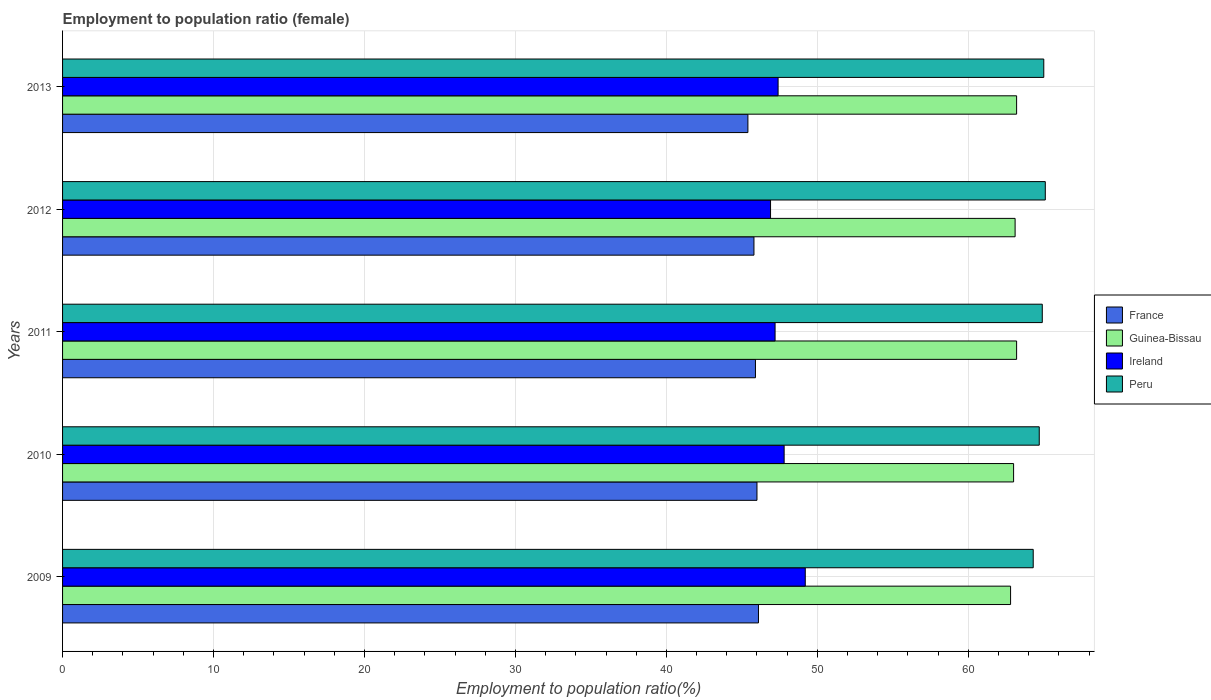How many groups of bars are there?
Your response must be concise. 5. Are the number of bars on each tick of the Y-axis equal?
Your answer should be compact. Yes. How many bars are there on the 4th tick from the bottom?
Offer a terse response. 4. What is the employment to population ratio in Peru in 2011?
Your response must be concise. 64.9. Across all years, what is the maximum employment to population ratio in Guinea-Bissau?
Provide a short and direct response. 63.2. Across all years, what is the minimum employment to population ratio in Peru?
Offer a very short reply. 64.3. What is the total employment to population ratio in Ireland in the graph?
Provide a short and direct response. 238.5. What is the difference between the employment to population ratio in Guinea-Bissau in 2009 and that in 2011?
Provide a short and direct response. -0.4. What is the difference between the employment to population ratio in Ireland in 2009 and the employment to population ratio in France in 2011?
Offer a terse response. 3.3. What is the average employment to population ratio in Ireland per year?
Make the answer very short. 47.7. In the year 2010, what is the difference between the employment to population ratio in Guinea-Bissau and employment to population ratio in Peru?
Make the answer very short. -1.7. What is the ratio of the employment to population ratio in Guinea-Bissau in 2010 to that in 2011?
Provide a succinct answer. 1. Is the employment to population ratio in France in 2010 less than that in 2012?
Make the answer very short. No. What is the difference between the highest and the second highest employment to population ratio in France?
Keep it short and to the point. 0.1. What is the difference between the highest and the lowest employment to population ratio in Peru?
Your response must be concise. 0.8. In how many years, is the employment to population ratio in France greater than the average employment to population ratio in France taken over all years?
Ensure brevity in your answer.  3. Is the sum of the employment to population ratio in Guinea-Bissau in 2009 and 2010 greater than the maximum employment to population ratio in Peru across all years?
Your answer should be very brief. Yes. Is it the case that in every year, the sum of the employment to population ratio in Guinea-Bissau and employment to population ratio in France is greater than the sum of employment to population ratio in Ireland and employment to population ratio in Peru?
Provide a succinct answer. No. What does the 3rd bar from the top in 2009 represents?
Provide a succinct answer. Guinea-Bissau. What does the 4th bar from the bottom in 2012 represents?
Your response must be concise. Peru. How many bars are there?
Ensure brevity in your answer.  20. Are all the bars in the graph horizontal?
Your answer should be very brief. Yes. Are the values on the major ticks of X-axis written in scientific E-notation?
Your answer should be compact. No. Does the graph contain any zero values?
Offer a terse response. No. Does the graph contain grids?
Give a very brief answer. Yes. Where does the legend appear in the graph?
Your answer should be very brief. Center right. How are the legend labels stacked?
Provide a succinct answer. Vertical. What is the title of the graph?
Your response must be concise. Employment to population ratio (female). Does "Greenland" appear as one of the legend labels in the graph?
Make the answer very short. No. What is the Employment to population ratio(%) of France in 2009?
Give a very brief answer. 46.1. What is the Employment to population ratio(%) of Guinea-Bissau in 2009?
Your response must be concise. 62.8. What is the Employment to population ratio(%) in Ireland in 2009?
Ensure brevity in your answer.  49.2. What is the Employment to population ratio(%) in Peru in 2009?
Offer a very short reply. 64.3. What is the Employment to population ratio(%) of France in 2010?
Offer a terse response. 46. What is the Employment to population ratio(%) in Guinea-Bissau in 2010?
Your response must be concise. 63. What is the Employment to population ratio(%) of Ireland in 2010?
Provide a short and direct response. 47.8. What is the Employment to population ratio(%) in Peru in 2010?
Make the answer very short. 64.7. What is the Employment to population ratio(%) of France in 2011?
Provide a short and direct response. 45.9. What is the Employment to population ratio(%) of Guinea-Bissau in 2011?
Give a very brief answer. 63.2. What is the Employment to population ratio(%) in Ireland in 2011?
Your answer should be very brief. 47.2. What is the Employment to population ratio(%) in Peru in 2011?
Ensure brevity in your answer.  64.9. What is the Employment to population ratio(%) of France in 2012?
Make the answer very short. 45.8. What is the Employment to population ratio(%) of Guinea-Bissau in 2012?
Give a very brief answer. 63.1. What is the Employment to population ratio(%) in Ireland in 2012?
Make the answer very short. 46.9. What is the Employment to population ratio(%) of Peru in 2012?
Provide a succinct answer. 65.1. What is the Employment to population ratio(%) of France in 2013?
Offer a terse response. 45.4. What is the Employment to population ratio(%) in Guinea-Bissau in 2013?
Make the answer very short. 63.2. What is the Employment to population ratio(%) of Ireland in 2013?
Offer a terse response. 47.4. What is the Employment to population ratio(%) of Peru in 2013?
Your response must be concise. 65. Across all years, what is the maximum Employment to population ratio(%) of France?
Your response must be concise. 46.1. Across all years, what is the maximum Employment to population ratio(%) of Guinea-Bissau?
Your answer should be compact. 63.2. Across all years, what is the maximum Employment to population ratio(%) of Ireland?
Your answer should be compact. 49.2. Across all years, what is the maximum Employment to population ratio(%) of Peru?
Your answer should be compact. 65.1. Across all years, what is the minimum Employment to population ratio(%) of France?
Your answer should be very brief. 45.4. Across all years, what is the minimum Employment to population ratio(%) of Guinea-Bissau?
Ensure brevity in your answer.  62.8. Across all years, what is the minimum Employment to population ratio(%) of Ireland?
Offer a terse response. 46.9. Across all years, what is the minimum Employment to population ratio(%) in Peru?
Your answer should be compact. 64.3. What is the total Employment to population ratio(%) in France in the graph?
Provide a succinct answer. 229.2. What is the total Employment to population ratio(%) in Guinea-Bissau in the graph?
Make the answer very short. 315.3. What is the total Employment to population ratio(%) in Ireland in the graph?
Your answer should be very brief. 238.5. What is the total Employment to population ratio(%) of Peru in the graph?
Offer a very short reply. 324. What is the difference between the Employment to population ratio(%) of Guinea-Bissau in 2009 and that in 2010?
Offer a terse response. -0.2. What is the difference between the Employment to population ratio(%) of Peru in 2009 and that in 2010?
Offer a very short reply. -0.4. What is the difference between the Employment to population ratio(%) of France in 2009 and that in 2011?
Your answer should be compact. 0.2. What is the difference between the Employment to population ratio(%) of Guinea-Bissau in 2009 and that in 2011?
Your answer should be very brief. -0.4. What is the difference between the Employment to population ratio(%) in Ireland in 2009 and that in 2011?
Ensure brevity in your answer.  2. What is the difference between the Employment to population ratio(%) in France in 2009 and that in 2012?
Your response must be concise. 0.3. What is the difference between the Employment to population ratio(%) of Peru in 2009 and that in 2012?
Give a very brief answer. -0.8. What is the difference between the Employment to population ratio(%) of Guinea-Bissau in 2009 and that in 2013?
Ensure brevity in your answer.  -0.4. What is the difference between the Employment to population ratio(%) in Ireland in 2010 and that in 2011?
Ensure brevity in your answer.  0.6. What is the difference between the Employment to population ratio(%) of Guinea-Bissau in 2010 and that in 2012?
Give a very brief answer. -0.1. What is the difference between the Employment to population ratio(%) of Ireland in 2010 and that in 2012?
Your answer should be compact. 0.9. What is the difference between the Employment to population ratio(%) of Guinea-Bissau in 2010 and that in 2013?
Ensure brevity in your answer.  -0.2. What is the difference between the Employment to population ratio(%) of Ireland in 2010 and that in 2013?
Your response must be concise. 0.4. What is the difference between the Employment to population ratio(%) of Peru in 2010 and that in 2013?
Give a very brief answer. -0.3. What is the difference between the Employment to population ratio(%) in Guinea-Bissau in 2011 and that in 2012?
Provide a short and direct response. 0.1. What is the difference between the Employment to population ratio(%) in Peru in 2011 and that in 2012?
Make the answer very short. -0.2. What is the difference between the Employment to population ratio(%) in France in 2011 and that in 2013?
Provide a short and direct response. 0.5. What is the difference between the Employment to population ratio(%) of Guinea-Bissau in 2011 and that in 2013?
Offer a very short reply. 0. What is the difference between the Employment to population ratio(%) in Peru in 2011 and that in 2013?
Make the answer very short. -0.1. What is the difference between the Employment to population ratio(%) of Ireland in 2012 and that in 2013?
Keep it short and to the point. -0.5. What is the difference between the Employment to population ratio(%) in Peru in 2012 and that in 2013?
Provide a short and direct response. 0.1. What is the difference between the Employment to population ratio(%) in France in 2009 and the Employment to population ratio(%) in Guinea-Bissau in 2010?
Offer a terse response. -16.9. What is the difference between the Employment to population ratio(%) in France in 2009 and the Employment to population ratio(%) in Ireland in 2010?
Provide a short and direct response. -1.7. What is the difference between the Employment to population ratio(%) of France in 2009 and the Employment to population ratio(%) of Peru in 2010?
Give a very brief answer. -18.6. What is the difference between the Employment to population ratio(%) in Guinea-Bissau in 2009 and the Employment to population ratio(%) in Ireland in 2010?
Your answer should be compact. 15. What is the difference between the Employment to population ratio(%) in Ireland in 2009 and the Employment to population ratio(%) in Peru in 2010?
Provide a short and direct response. -15.5. What is the difference between the Employment to population ratio(%) of France in 2009 and the Employment to population ratio(%) of Guinea-Bissau in 2011?
Your response must be concise. -17.1. What is the difference between the Employment to population ratio(%) in France in 2009 and the Employment to population ratio(%) in Ireland in 2011?
Your answer should be very brief. -1.1. What is the difference between the Employment to population ratio(%) in France in 2009 and the Employment to population ratio(%) in Peru in 2011?
Your response must be concise. -18.8. What is the difference between the Employment to population ratio(%) of Ireland in 2009 and the Employment to population ratio(%) of Peru in 2011?
Offer a terse response. -15.7. What is the difference between the Employment to population ratio(%) of Ireland in 2009 and the Employment to population ratio(%) of Peru in 2012?
Make the answer very short. -15.9. What is the difference between the Employment to population ratio(%) of France in 2009 and the Employment to population ratio(%) of Guinea-Bissau in 2013?
Provide a succinct answer. -17.1. What is the difference between the Employment to population ratio(%) of France in 2009 and the Employment to population ratio(%) of Ireland in 2013?
Offer a terse response. -1.3. What is the difference between the Employment to population ratio(%) in France in 2009 and the Employment to population ratio(%) in Peru in 2013?
Ensure brevity in your answer.  -18.9. What is the difference between the Employment to population ratio(%) of Guinea-Bissau in 2009 and the Employment to population ratio(%) of Peru in 2013?
Provide a short and direct response. -2.2. What is the difference between the Employment to population ratio(%) of Ireland in 2009 and the Employment to population ratio(%) of Peru in 2013?
Your answer should be very brief. -15.8. What is the difference between the Employment to population ratio(%) in France in 2010 and the Employment to population ratio(%) in Guinea-Bissau in 2011?
Make the answer very short. -17.2. What is the difference between the Employment to population ratio(%) in France in 2010 and the Employment to population ratio(%) in Ireland in 2011?
Keep it short and to the point. -1.2. What is the difference between the Employment to population ratio(%) in France in 2010 and the Employment to population ratio(%) in Peru in 2011?
Offer a very short reply. -18.9. What is the difference between the Employment to population ratio(%) of Guinea-Bissau in 2010 and the Employment to population ratio(%) of Ireland in 2011?
Your answer should be compact. 15.8. What is the difference between the Employment to population ratio(%) of Ireland in 2010 and the Employment to population ratio(%) of Peru in 2011?
Provide a succinct answer. -17.1. What is the difference between the Employment to population ratio(%) of France in 2010 and the Employment to population ratio(%) of Guinea-Bissau in 2012?
Ensure brevity in your answer.  -17.1. What is the difference between the Employment to population ratio(%) of France in 2010 and the Employment to population ratio(%) of Ireland in 2012?
Keep it short and to the point. -0.9. What is the difference between the Employment to population ratio(%) in France in 2010 and the Employment to population ratio(%) in Peru in 2012?
Offer a terse response. -19.1. What is the difference between the Employment to population ratio(%) in Guinea-Bissau in 2010 and the Employment to population ratio(%) in Ireland in 2012?
Offer a terse response. 16.1. What is the difference between the Employment to population ratio(%) of Ireland in 2010 and the Employment to population ratio(%) of Peru in 2012?
Your response must be concise. -17.3. What is the difference between the Employment to population ratio(%) of France in 2010 and the Employment to population ratio(%) of Guinea-Bissau in 2013?
Give a very brief answer. -17.2. What is the difference between the Employment to population ratio(%) in France in 2010 and the Employment to population ratio(%) in Peru in 2013?
Keep it short and to the point. -19. What is the difference between the Employment to population ratio(%) of Guinea-Bissau in 2010 and the Employment to population ratio(%) of Ireland in 2013?
Your answer should be very brief. 15.6. What is the difference between the Employment to population ratio(%) of Guinea-Bissau in 2010 and the Employment to population ratio(%) of Peru in 2013?
Offer a very short reply. -2. What is the difference between the Employment to population ratio(%) of Ireland in 2010 and the Employment to population ratio(%) of Peru in 2013?
Provide a short and direct response. -17.2. What is the difference between the Employment to population ratio(%) in France in 2011 and the Employment to population ratio(%) in Guinea-Bissau in 2012?
Ensure brevity in your answer.  -17.2. What is the difference between the Employment to population ratio(%) of France in 2011 and the Employment to population ratio(%) of Peru in 2012?
Provide a succinct answer. -19.2. What is the difference between the Employment to population ratio(%) of Guinea-Bissau in 2011 and the Employment to population ratio(%) of Peru in 2012?
Your response must be concise. -1.9. What is the difference between the Employment to population ratio(%) in Ireland in 2011 and the Employment to population ratio(%) in Peru in 2012?
Your response must be concise. -17.9. What is the difference between the Employment to population ratio(%) in France in 2011 and the Employment to population ratio(%) in Guinea-Bissau in 2013?
Provide a short and direct response. -17.3. What is the difference between the Employment to population ratio(%) of France in 2011 and the Employment to population ratio(%) of Ireland in 2013?
Give a very brief answer. -1.5. What is the difference between the Employment to population ratio(%) in France in 2011 and the Employment to population ratio(%) in Peru in 2013?
Give a very brief answer. -19.1. What is the difference between the Employment to population ratio(%) of Guinea-Bissau in 2011 and the Employment to population ratio(%) of Ireland in 2013?
Offer a terse response. 15.8. What is the difference between the Employment to population ratio(%) of Guinea-Bissau in 2011 and the Employment to population ratio(%) of Peru in 2013?
Keep it short and to the point. -1.8. What is the difference between the Employment to population ratio(%) in Ireland in 2011 and the Employment to population ratio(%) in Peru in 2013?
Make the answer very short. -17.8. What is the difference between the Employment to population ratio(%) of France in 2012 and the Employment to population ratio(%) of Guinea-Bissau in 2013?
Offer a very short reply. -17.4. What is the difference between the Employment to population ratio(%) of France in 2012 and the Employment to population ratio(%) of Peru in 2013?
Your response must be concise. -19.2. What is the difference between the Employment to population ratio(%) in Guinea-Bissau in 2012 and the Employment to population ratio(%) in Ireland in 2013?
Ensure brevity in your answer.  15.7. What is the difference between the Employment to population ratio(%) in Ireland in 2012 and the Employment to population ratio(%) in Peru in 2013?
Your response must be concise. -18.1. What is the average Employment to population ratio(%) in France per year?
Provide a short and direct response. 45.84. What is the average Employment to population ratio(%) in Guinea-Bissau per year?
Ensure brevity in your answer.  63.06. What is the average Employment to population ratio(%) of Ireland per year?
Your response must be concise. 47.7. What is the average Employment to population ratio(%) in Peru per year?
Your answer should be very brief. 64.8. In the year 2009, what is the difference between the Employment to population ratio(%) of France and Employment to population ratio(%) of Guinea-Bissau?
Provide a succinct answer. -16.7. In the year 2009, what is the difference between the Employment to population ratio(%) in France and Employment to population ratio(%) in Peru?
Ensure brevity in your answer.  -18.2. In the year 2009, what is the difference between the Employment to population ratio(%) in Guinea-Bissau and Employment to population ratio(%) in Ireland?
Ensure brevity in your answer.  13.6. In the year 2009, what is the difference between the Employment to population ratio(%) of Ireland and Employment to population ratio(%) of Peru?
Your answer should be compact. -15.1. In the year 2010, what is the difference between the Employment to population ratio(%) in France and Employment to population ratio(%) in Guinea-Bissau?
Offer a very short reply. -17. In the year 2010, what is the difference between the Employment to population ratio(%) of France and Employment to population ratio(%) of Ireland?
Ensure brevity in your answer.  -1.8. In the year 2010, what is the difference between the Employment to population ratio(%) of France and Employment to population ratio(%) of Peru?
Offer a very short reply. -18.7. In the year 2010, what is the difference between the Employment to population ratio(%) in Ireland and Employment to population ratio(%) in Peru?
Give a very brief answer. -16.9. In the year 2011, what is the difference between the Employment to population ratio(%) of France and Employment to population ratio(%) of Guinea-Bissau?
Provide a short and direct response. -17.3. In the year 2011, what is the difference between the Employment to population ratio(%) in France and Employment to population ratio(%) in Ireland?
Provide a succinct answer. -1.3. In the year 2011, what is the difference between the Employment to population ratio(%) of Guinea-Bissau and Employment to population ratio(%) of Ireland?
Ensure brevity in your answer.  16. In the year 2011, what is the difference between the Employment to population ratio(%) of Guinea-Bissau and Employment to population ratio(%) of Peru?
Your answer should be very brief. -1.7. In the year 2011, what is the difference between the Employment to population ratio(%) of Ireland and Employment to population ratio(%) of Peru?
Make the answer very short. -17.7. In the year 2012, what is the difference between the Employment to population ratio(%) of France and Employment to population ratio(%) of Guinea-Bissau?
Provide a succinct answer. -17.3. In the year 2012, what is the difference between the Employment to population ratio(%) of France and Employment to population ratio(%) of Ireland?
Offer a very short reply. -1.1. In the year 2012, what is the difference between the Employment to population ratio(%) of France and Employment to population ratio(%) of Peru?
Your response must be concise. -19.3. In the year 2012, what is the difference between the Employment to population ratio(%) of Guinea-Bissau and Employment to population ratio(%) of Ireland?
Ensure brevity in your answer.  16.2. In the year 2012, what is the difference between the Employment to population ratio(%) of Ireland and Employment to population ratio(%) of Peru?
Offer a terse response. -18.2. In the year 2013, what is the difference between the Employment to population ratio(%) in France and Employment to population ratio(%) in Guinea-Bissau?
Your response must be concise. -17.8. In the year 2013, what is the difference between the Employment to population ratio(%) in France and Employment to population ratio(%) in Ireland?
Give a very brief answer. -2. In the year 2013, what is the difference between the Employment to population ratio(%) of France and Employment to population ratio(%) of Peru?
Provide a short and direct response. -19.6. In the year 2013, what is the difference between the Employment to population ratio(%) in Guinea-Bissau and Employment to population ratio(%) in Ireland?
Your answer should be compact. 15.8. In the year 2013, what is the difference between the Employment to population ratio(%) in Ireland and Employment to population ratio(%) in Peru?
Your response must be concise. -17.6. What is the ratio of the Employment to population ratio(%) in France in 2009 to that in 2010?
Make the answer very short. 1. What is the ratio of the Employment to population ratio(%) of Ireland in 2009 to that in 2010?
Keep it short and to the point. 1.03. What is the ratio of the Employment to population ratio(%) of France in 2009 to that in 2011?
Provide a short and direct response. 1. What is the ratio of the Employment to population ratio(%) of Guinea-Bissau in 2009 to that in 2011?
Your response must be concise. 0.99. What is the ratio of the Employment to population ratio(%) in Ireland in 2009 to that in 2011?
Ensure brevity in your answer.  1.04. What is the ratio of the Employment to population ratio(%) of Peru in 2009 to that in 2011?
Ensure brevity in your answer.  0.99. What is the ratio of the Employment to population ratio(%) in France in 2009 to that in 2012?
Offer a very short reply. 1.01. What is the ratio of the Employment to population ratio(%) in Guinea-Bissau in 2009 to that in 2012?
Provide a succinct answer. 1. What is the ratio of the Employment to population ratio(%) in Ireland in 2009 to that in 2012?
Offer a very short reply. 1.05. What is the ratio of the Employment to population ratio(%) in France in 2009 to that in 2013?
Your answer should be compact. 1.02. What is the ratio of the Employment to population ratio(%) of Guinea-Bissau in 2009 to that in 2013?
Your response must be concise. 0.99. What is the ratio of the Employment to population ratio(%) of Ireland in 2009 to that in 2013?
Provide a short and direct response. 1.04. What is the ratio of the Employment to population ratio(%) in Guinea-Bissau in 2010 to that in 2011?
Provide a succinct answer. 1. What is the ratio of the Employment to population ratio(%) in Ireland in 2010 to that in 2011?
Make the answer very short. 1.01. What is the ratio of the Employment to population ratio(%) in Ireland in 2010 to that in 2012?
Your answer should be compact. 1.02. What is the ratio of the Employment to population ratio(%) in Peru in 2010 to that in 2012?
Provide a short and direct response. 0.99. What is the ratio of the Employment to population ratio(%) of France in 2010 to that in 2013?
Provide a succinct answer. 1.01. What is the ratio of the Employment to population ratio(%) of Guinea-Bissau in 2010 to that in 2013?
Ensure brevity in your answer.  1. What is the ratio of the Employment to population ratio(%) of Ireland in 2010 to that in 2013?
Your answer should be compact. 1.01. What is the ratio of the Employment to population ratio(%) in Peru in 2010 to that in 2013?
Give a very brief answer. 1. What is the ratio of the Employment to population ratio(%) of Ireland in 2011 to that in 2012?
Offer a terse response. 1.01. What is the ratio of the Employment to population ratio(%) in Peru in 2011 to that in 2012?
Your response must be concise. 1. What is the ratio of the Employment to population ratio(%) in Guinea-Bissau in 2011 to that in 2013?
Offer a terse response. 1. What is the ratio of the Employment to population ratio(%) of France in 2012 to that in 2013?
Make the answer very short. 1.01. What is the ratio of the Employment to population ratio(%) in Guinea-Bissau in 2012 to that in 2013?
Make the answer very short. 1. What is the difference between the highest and the second highest Employment to population ratio(%) in Guinea-Bissau?
Offer a terse response. 0. What is the difference between the highest and the second highest Employment to population ratio(%) of Peru?
Your answer should be compact. 0.1. What is the difference between the highest and the lowest Employment to population ratio(%) of Guinea-Bissau?
Keep it short and to the point. 0.4. What is the difference between the highest and the lowest Employment to population ratio(%) in Peru?
Your response must be concise. 0.8. 